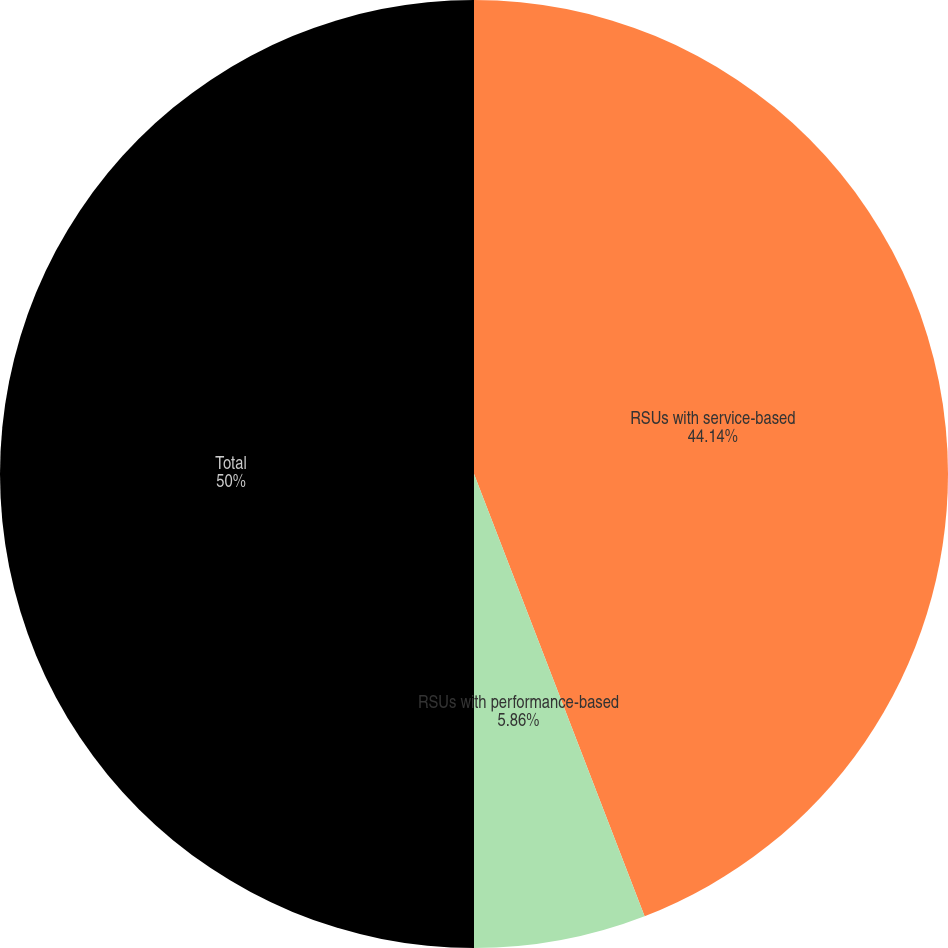Convert chart to OTSL. <chart><loc_0><loc_0><loc_500><loc_500><pie_chart><fcel>RSUs with service-based<fcel>RSUs with performance-based<fcel>Total<nl><fcel>44.14%<fcel>5.86%<fcel>50.0%<nl></chart> 